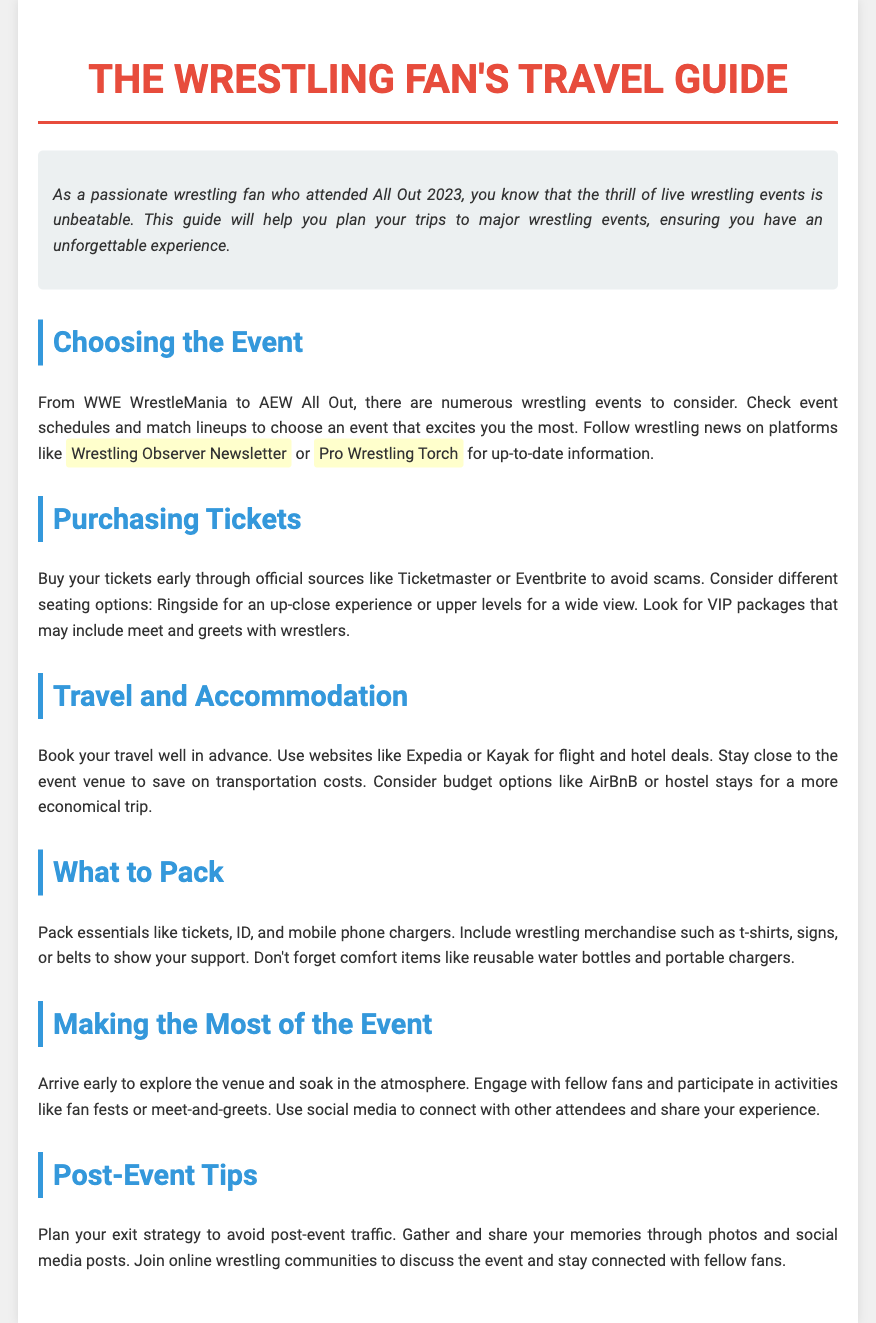What are some examples of wrestling events listed? The document mentions multiple events including WWE WrestleMania and AEW All Out as examples of wrestling events to consider.
Answer: WWE WrestleMania, AEW All Out Where can I buy tickets? The guide suggests purchasing tickets through official sources like Ticketmaster or Eventbrite.
Answer: Ticketmaster, Eventbrite What should I pack for a wrestling event? The essential items to pack include tickets, ID, mobile phone chargers, and wrestling merchandise to show support.
Answer: Tickets, ID, mobile phone chargers, wrestling merchandise What is a suggested budget accommodation option? The document recommends options like AirBnB or hostels for a more economical trip.
Answer: AirBnB, hostels What should you do to make the most of the event? The document advises arriving early to explore the venue and engage with fellow fans.
Answer: Arrive early, engage with fellow fans Which platforms can provide up-to-date wrestling news? The guide lists Wrestling Observer Newsletter and Pro Wrestling Torch as platforms to check for news.
Answer: Wrestling Observer Newsletter, Pro Wrestling Torch What is recommended for post-event activities? The document suggests gathering and sharing memories through photos and social media posts after the event.
Answer: Sharing memories through photos and social media What should you consider when booking travel? The guide emphasizes booking your travel well in advance to secure good deals.
Answer: Book travel in advance 